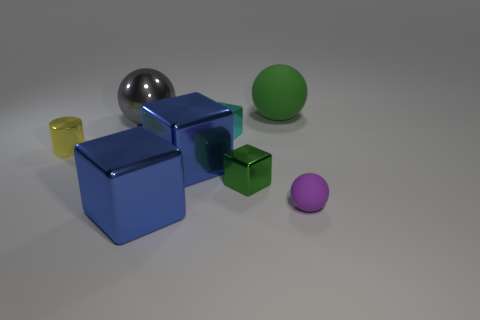Subtract all small cyan cubes. How many cubes are left? 3 Add 2 large purple rubber cylinders. How many objects exist? 10 Subtract all green cubes. How many cubes are left? 3 Subtract all cylinders. How many objects are left? 7 Subtract 2 cubes. How many cubes are left? 2 Subtract all green cylinders. How many purple cubes are left? 0 Subtract all large blue cylinders. Subtract all big matte spheres. How many objects are left? 7 Add 7 big matte spheres. How many big matte spheres are left? 8 Add 6 tiny cyan metal blocks. How many tiny cyan metal blocks exist? 7 Subtract 1 gray spheres. How many objects are left? 7 